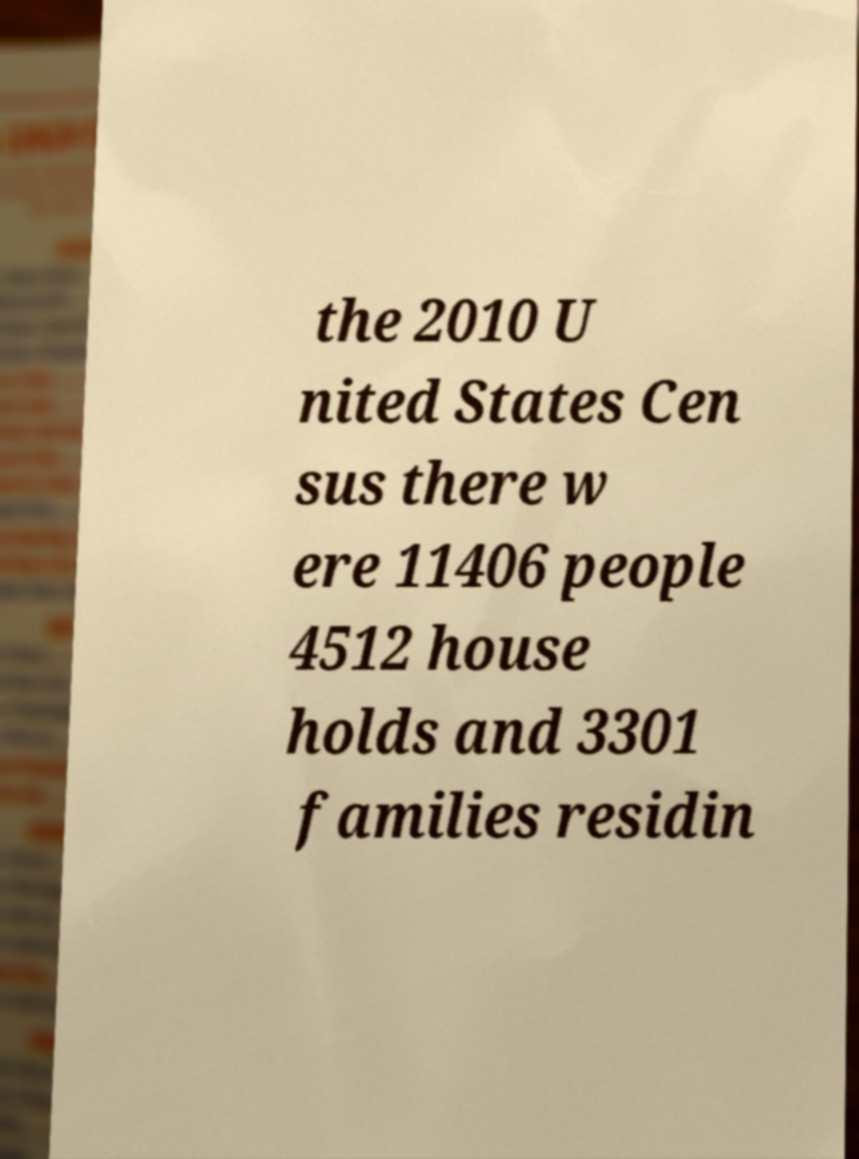What messages or text are displayed in this image? I need them in a readable, typed format. the 2010 U nited States Cen sus there w ere 11406 people 4512 house holds and 3301 families residin 